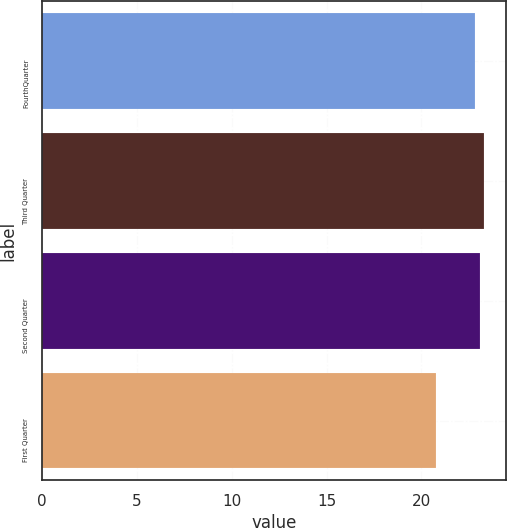Convert chart to OTSL. <chart><loc_0><loc_0><loc_500><loc_500><bar_chart><fcel>FourthQuarter<fcel>Third Quarter<fcel>Second Quarter<fcel>First Quarter<nl><fcel>22.84<fcel>23.3<fcel>23.07<fcel>20.78<nl></chart> 